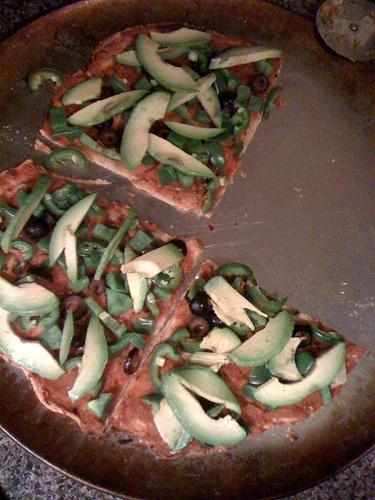What is on the tray?

Choices:
A) cookie
B) hand
C) cake
D) avocado avocado 